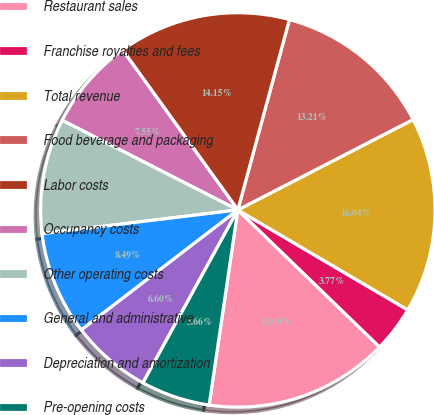<chart> <loc_0><loc_0><loc_500><loc_500><pie_chart><fcel>Restaurant sales<fcel>Franchise royalties and fees<fcel>Total revenue<fcel>Food beverage and packaging<fcel>Labor costs<fcel>Occupancy costs<fcel>Other operating costs<fcel>General and administrative<fcel>Depreciation and amortization<fcel>Pre-opening costs<nl><fcel>15.09%<fcel>3.77%<fcel>16.04%<fcel>13.21%<fcel>14.15%<fcel>7.55%<fcel>9.43%<fcel>8.49%<fcel>6.6%<fcel>5.66%<nl></chart> 